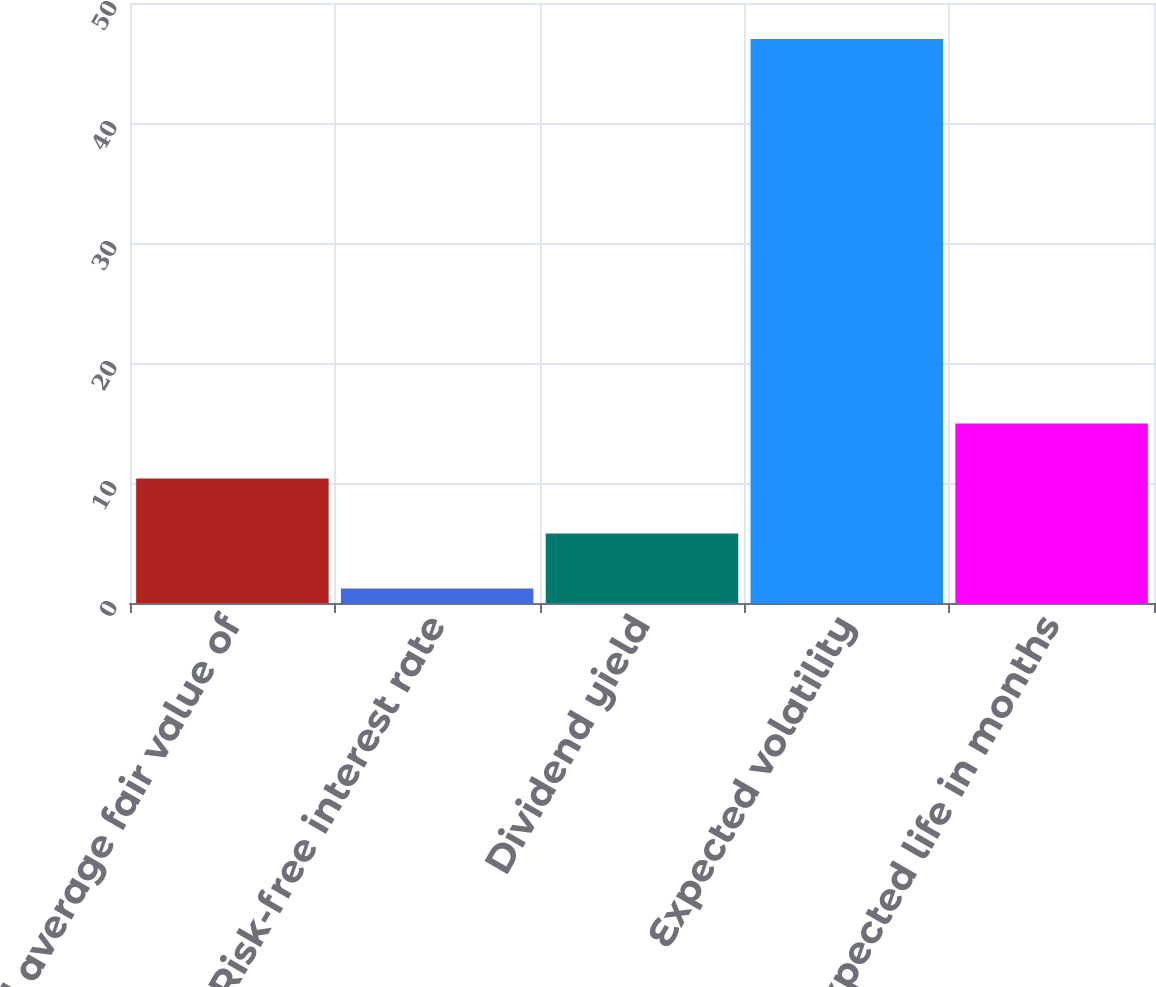Convert chart to OTSL. <chart><loc_0><loc_0><loc_500><loc_500><bar_chart><fcel>Weighted average fair value of<fcel>Risk-free interest rate<fcel>Dividend yield<fcel>Expected volatility<fcel>Expected life in months<nl><fcel>10.37<fcel>1.21<fcel>5.79<fcel>47<fcel>14.95<nl></chart> 